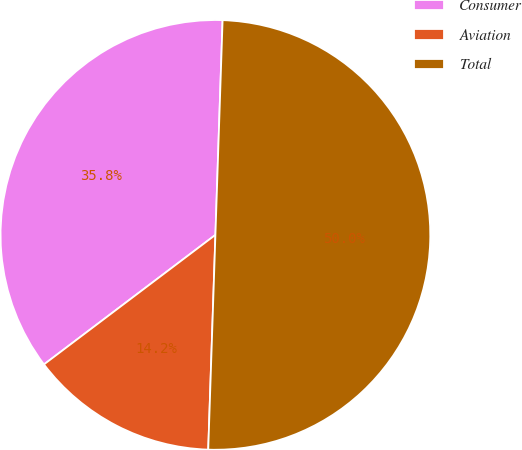<chart> <loc_0><loc_0><loc_500><loc_500><pie_chart><fcel>Consumer<fcel>Aviation<fcel>Total<nl><fcel>35.83%<fcel>14.17%<fcel>50.0%<nl></chart> 